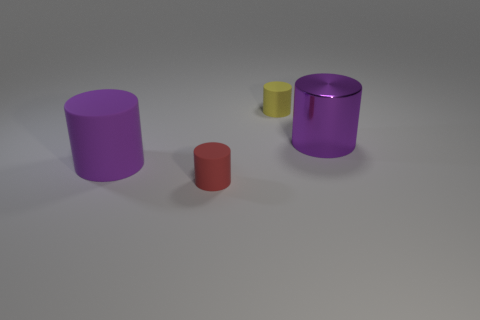Are there any large cylinders that have the same color as the large metal object? Yes, there are two large cylinders in the image that share the same purple hue as the large metal-like cylinder on the right. 